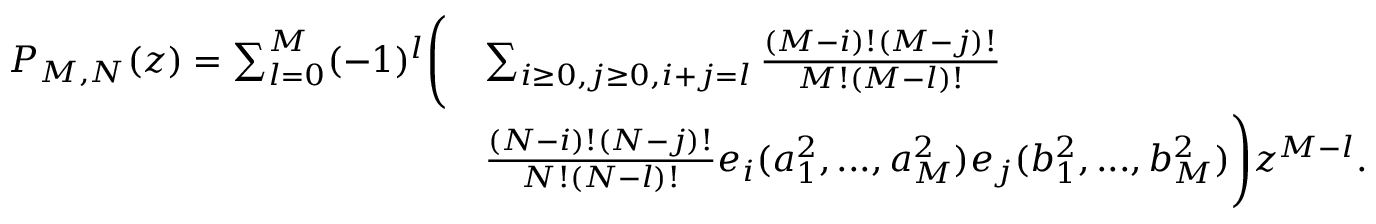<formula> <loc_0><loc_0><loc_500><loc_500>\begin{array} { r l } { P _ { M , N } ( z ) = \sum _ { l = 0 } ^ { M } ( - 1 ) ^ { l } \left ( } & { \sum _ { i \geq 0 , j \geq 0 , i + j = l } \frac { ( M - i ) ! ( M - j ) ! } { M ! ( M - l ) ! } } \\ & { \frac { ( N - i ) ! ( N - j ) ! } { N ! ( N - l ) ! } e _ { i } ( a _ { 1 } ^ { 2 } , \dots , a _ { M } ^ { 2 } ) e _ { j } ( b _ { 1 } ^ { 2 } , \dots , b _ { M } ^ { 2 } ) \right ) z ^ { M - l } . } \end{array}</formula> 